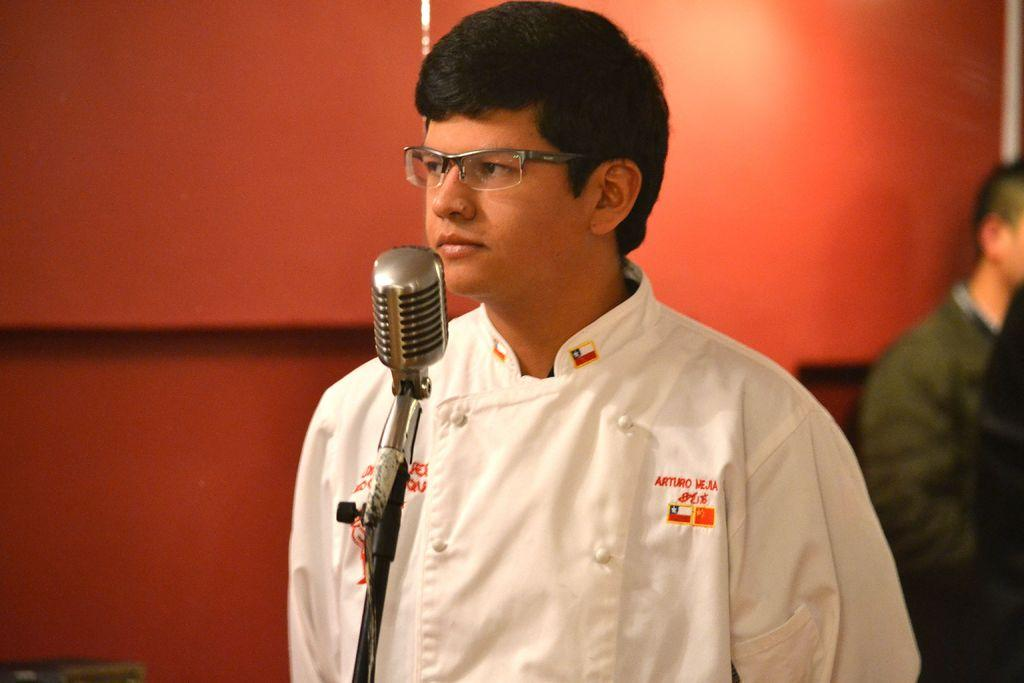Who is the main subject in the image? There is a man in the image. What object is in front of the man? There is a microphone (mic) in front of the man. What can be seen in the background of the image? There is a wall in the background of the image. Are there any other people visible in the image? Yes, there is at least one person in the background of the image. How many frogs are jumping on the man's head in the image? There are no frogs present in the image, so it is not possible to determine how many might be jumping on the man's head. 